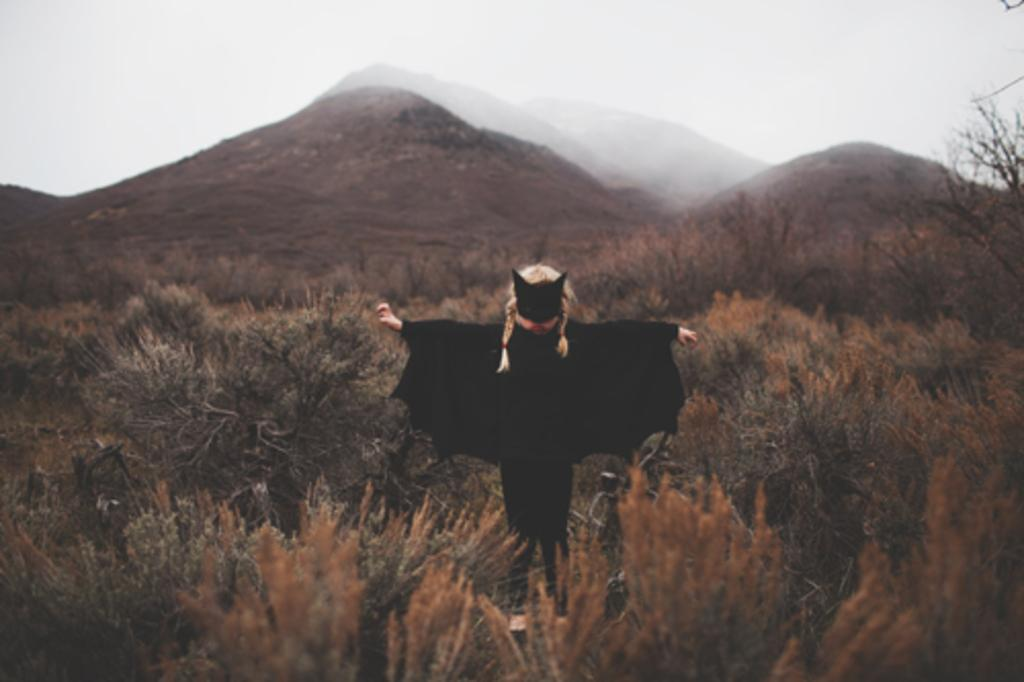What is the main subject of the image? There is a person standing in the image. Where is the person standing? The person is standing on the ground. What type of natural features can be seen in the image? Mountains and trees are visible in the image. What part of the natural environment is visible in the image? The sky is visible in the image. What type of drain can be seen in the image? There is no drain present in the image. How does the person's temper affect the mountains in the image? The person's temper does not affect the mountains in the image, as they are not interacting with each other. 